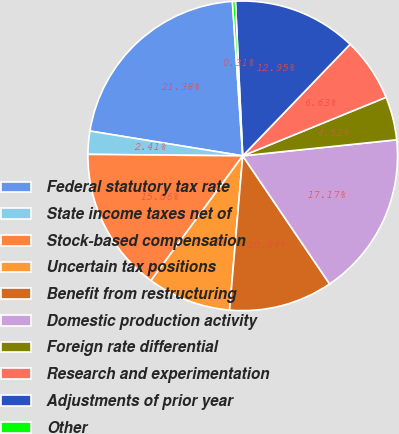<chart> <loc_0><loc_0><loc_500><loc_500><pie_chart><fcel>Federal statutory tax rate<fcel>State income taxes net of<fcel>Stock-based compensation<fcel>Uncertain tax positions<fcel>Benefit from restructuring<fcel>Domestic production activity<fcel>Foreign rate differential<fcel>Research and experimentation<fcel>Adjustments of prior year<fcel>Other<nl><fcel>21.38%<fcel>2.41%<fcel>15.06%<fcel>8.74%<fcel>10.84%<fcel>17.17%<fcel>4.52%<fcel>6.63%<fcel>12.95%<fcel>0.31%<nl></chart> 